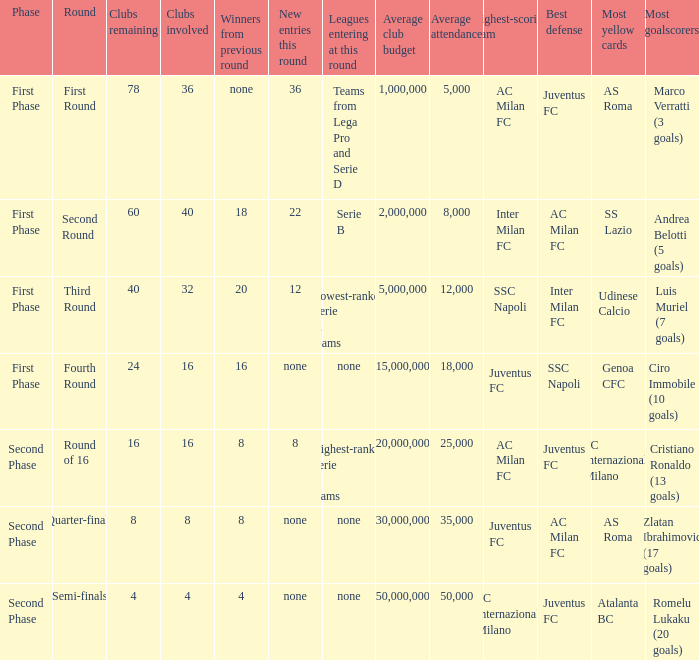The new entries this round was shown to be 12, in which phase would you find this? First Phase. 